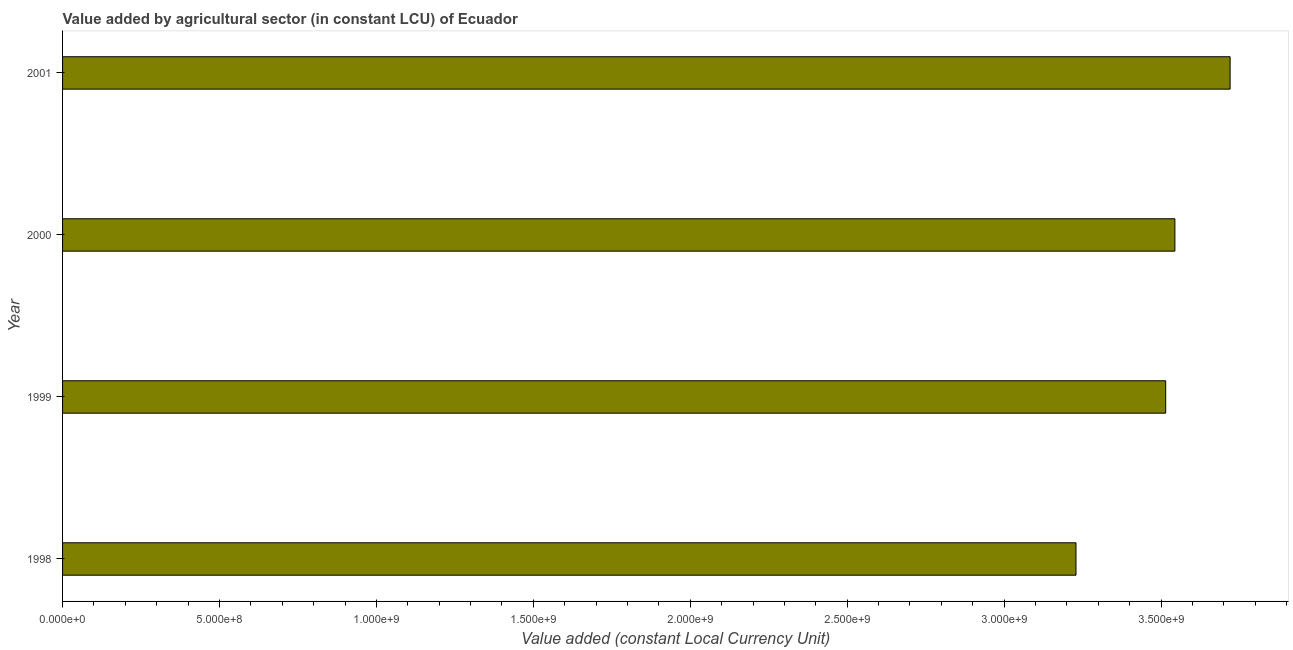Does the graph contain any zero values?
Give a very brief answer. No. What is the title of the graph?
Offer a very short reply. Value added by agricultural sector (in constant LCU) of Ecuador. What is the label or title of the X-axis?
Ensure brevity in your answer.  Value added (constant Local Currency Unit). What is the value added by agriculture sector in 2000?
Keep it short and to the point. 3.54e+09. Across all years, what is the maximum value added by agriculture sector?
Provide a short and direct response. 3.72e+09. Across all years, what is the minimum value added by agriculture sector?
Provide a short and direct response. 3.23e+09. In which year was the value added by agriculture sector maximum?
Your response must be concise. 2001. What is the sum of the value added by agriculture sector?
Your response must be concise. 1.40e+1. What is the difference between the value added by agriculture sector in 2000 and 2001?
Your answer should be very brief. -1.76e+08. What is the average value added by agriculture sector per year?
Keep it short and to the point. 3.50e+09. What is the median value added by agriculture sector?
Provide a short and direct response. 3.53e+09. In how many years, is the value added by agriculture sector greater than 2100000000 LCU?
Provide a succinct answer. 4. What is the ratio of the value added by agriculture sector in 2000 to that in 2001?
Offer a terse response. 0.95. Is the value added by agriculture sector in 1999 less than that in 2000?
Offer a terse response. Yes. Is the difference between the value added by agriculture sector in 1999 and 2000 greater than the difference between any two years?
Make the answer very short. No. What is the difference between the highest and the second highest value added by agriculture sector?
Provide a succinct answer. 1.76e+08. Is the sum of the value added by agriculture sector in 1998 and 2001 greater than the maximum value added by agriculture sector across all years?
Offer a terse response. Yes. What is the difference between the highest and the lowest value added by agriculture sector?
Your answer should be compact. 4.91e+08. In how many years, is the value added by agriculture sector greater than the average value added by agriculture sector taken over all years?
Your response must be concise. 3. Are all the bars in the graph horizontal?
Provide a succinct answer. Yes. What is the difference between two consecutive major ticks on the X-axis?
Your answer should be very brief. 5.00e+08. What is the Value added (constant Local Currency Unit) in 1998?
Keep it short and to the point. 3.23e+09. What is the Value added (constant Local Currency Unit) in 1999?
Your answer should be compact. 3.51e+09. What is the Value added (constant Local Currency Unit) in 2000?
Provide a succinct answer. 3.54e+09. What is the Value added (constant Local Currency Unit) in 2001?
Offer a very short reply. 3.72e+09. What is the difference between the Value added (constant Local Currency Unit) in 1998 and 1999?
Offer a terse response. -2.86e+08. What is the difference between the Value added (constant Local Currency Unit) in 1998 and 2000?
Provide a succinct answer. -3.15e+08. What is the difference between the Value added (constant Local Currency Unit) in 1998 and 2001?
Make the answer very short. -4.91e+08. What is the difference between the Value added (constant Local Currency Unit) in 1999 and 2000?
Keep it short and to the point. -2.93e+07. What is the difference between the Value added (constant Local Currency Unit) in 1999 and 2001?
Offer a very short reply. -2.05e+08. What is the difference between the Value added (constant Local Currency Unit) in 2000 and 2001?
Your response must be concise. -1.76e+08. What is the ratio of the Value added (constant Local Currency Unit) in 1998 to that in 1999?
Ensure brevity in your answer.  0.92. What is the ratio of the Value added (constant Local Currency Unit) in 1998 to that in 2000?
Provide a succinct answer. 0.91. What is the ratio of the Value added (constant Local Currency Unit) in 1998 to that in 2001?
Your response must be concise. 0.87. What is the ratio of the Value added (constant Local Currency Unit) in 1999 to that in 2000?
Your answer should be compact. 0.99. What is the ratio of the Value added (constant Local Currency Unit) in 1999 to that in 2001?
Your response must be concise. 0.94. What is the ratio of the Value added (constant Local Currency Unit) in 2000 to that in 2001?
Your response must be concise. 0.95. 